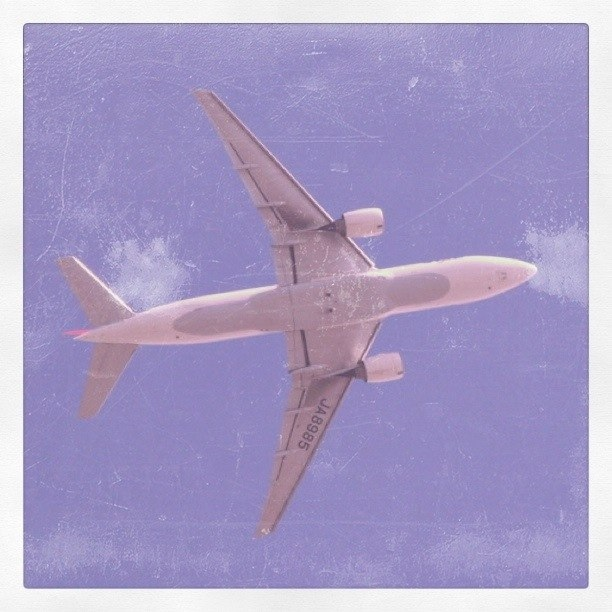Describe the objects in this image and their specific colors. I can see a airplane in white, darkgray, gray, and pink tones in this image. 